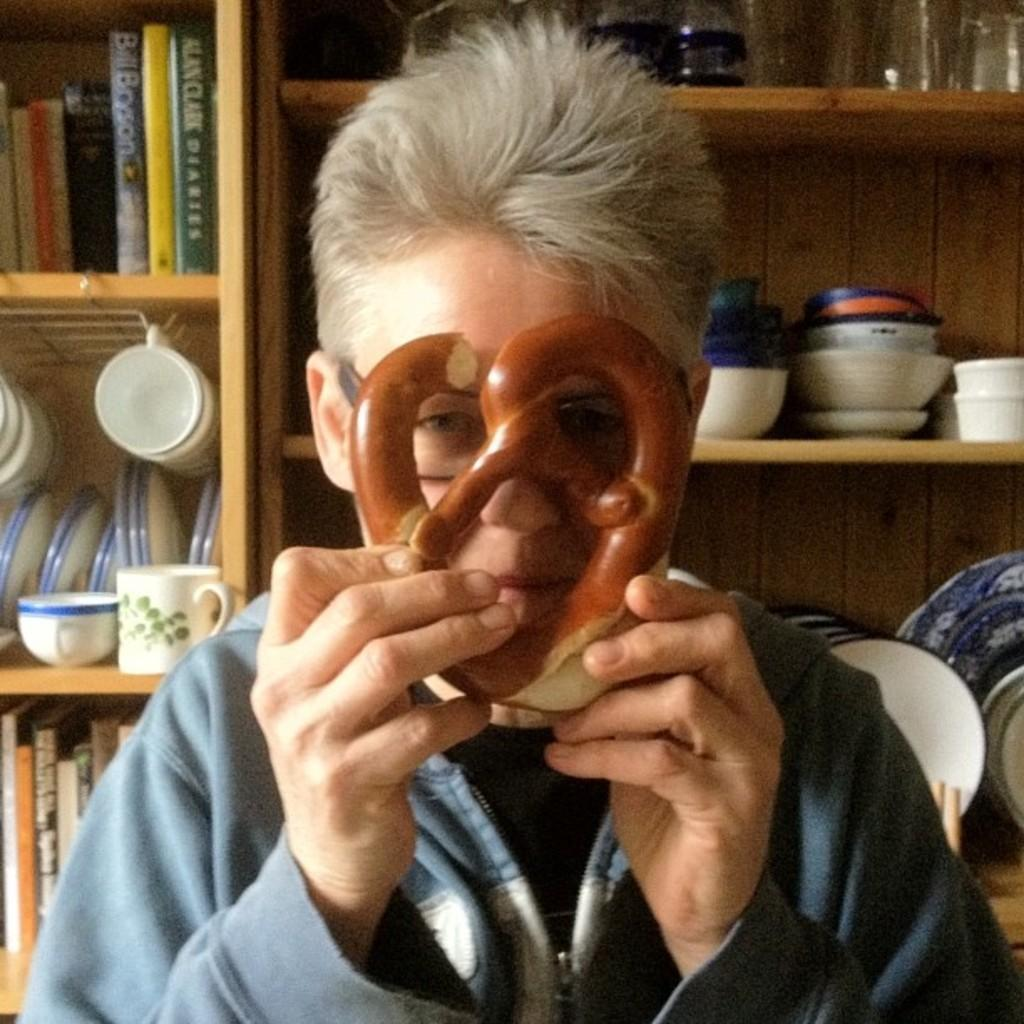What is the main subject of the image? There is a person standing in the center of the image. What is the person holding in the image? The person is holding an object. What can be seen in the background of the image? There are racks, books, plates, cups, and bowls in the background of the image. How many girls are visible in the image? There are no girls present in the image; it features a person holding an object and various items in the background. What type of comb is being used by the person in the image? There is no comb visible in the image. 